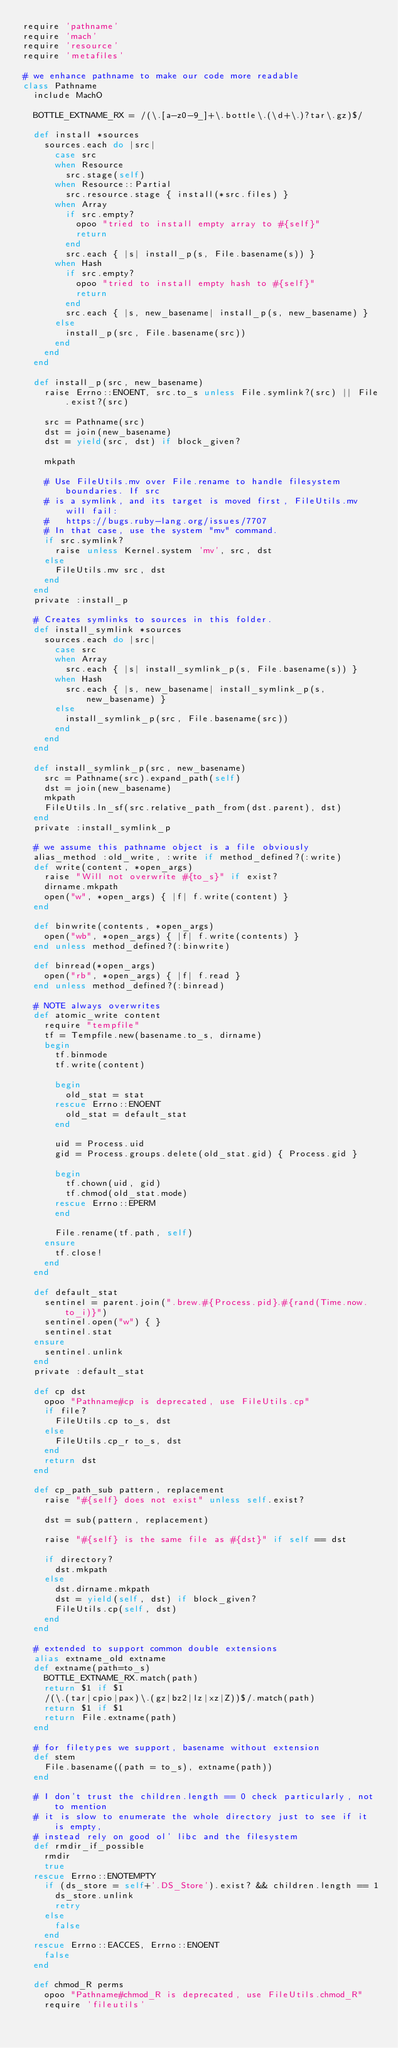Convert code to text. <code><loc_0><loc_0><loc_500><loc_500><_Ruby_>require 'pathname'
require 'mach'
require 'resource'
require 'metafiles'

# we enhance pathname to make our code more readable
class Pathname
  include MachO

  BOTTLE_EXTNAME_RX = /(\.[a-z0-9_]+\.bottle\.(\d+\.)?tar\.gz)$/

  def install *sources
    sources.each do |src|
      case src
      when Resource
        src.stage(self)
      when Resource::Partial
        src.resource.stage { install(*src.files) }
      when Array
        if src.empty?
          opoo "tried to install empty array to #{self}"
          return
        end
        src.each { |s| install_p(s, File.basename(s)) }
      when Hash
        if src.empty?
          opoo "tried to install empty hash to #{self}"
          return
        end
        src.each { |s, new_basename| install_p(s, new_basename) }
      else
        install_p(src, File.basename(src))
      end
    end
  end

  def install_p(src, new_basename)
    raise Errno::ENOENT, src.to_s unless File.symlink?(src) || File.exist?(src)

    src = Pathname(src)
    dst = join(new_basename)
    dst = yield(src, dst) if block_given?

    mkpath

    # Use FileUtils.mv over File.rename to handle filesystem boundaries. If src
    # is a symlink, and its target is moved first, FileUtils.mv will fail:
    #   https://bugs.ruby-lang.org/issues/7707
    # In that case, use the system "mv" command.
    if src.symlink?
      raise unless Kernel.system 'mv', src, dst
    else
      FileUtils.mv src, dst
    end
  end
  private :install_p

  # Creates symlinks to sources in this folder.
  def install_symlink *sources
    sources.each do |src|
      case src
      when Array
        src.each { |s| install_symlink_p(s, File.basename(s)) }
      when Hash
        src.each { |s, new_basename| install_symlink_p(s, new_basename) }
      else
        install_symlink_p(src, File.basename(src))
      end
    end
  end

  def install_symlink_p(src, new_basename)
    src = Pathname(src).expand_path(self)
    dst = join(new_basename)
    mkpath
    FileUtils.ln_sf(src.relative_path_from(dst.parent), dst)
  end
  private :install_symlink_p

  # we assume this pathname object is a file obviously
  alias_method :old_write, :write if method_defined?(:write)
  def write(content, *open_args)
    raise "Will not overwrite #{to_s}" if exist?
    dirname.mkpath
    open("w", *open_args) { |f| f.write(content) }
  end

  def binwrite(contents, *open_args)
    open("wb", *open_args) { |f| f.write(contents) }
  end unless method_defined?(:binwrite)

  def binread(*open_args)
    open("rb", *open_args) { |f| f.read }
  end unless method_defined?(:binread)

  # NOTE always overwrites
  def atomic_write content
    require "tempfile"
    tf = Tempfile.new(basename.to_s, dirname)
    begin
      tf.binmode
      tf.write(content)

      begin
        old_stat = stat
      rescue Errno::ENOENT
        old_stat = default_stat
      end

      uid = Process.uid
      gid = Process.groups.delete(old_stat.gid) { Process.gid }

      begin
        tf.chown(uid, gid)
        tf.chmod(old_stat.mode)
      rescue Errno::EPERM
      end

      File.rename(tf.path, self)
    ensure
      tf.close!
    end
  end

  def default_stat
    sentinel = parent.join(".brew.#{Process.pid}.#{rand(Time.now.to_i)}")
    sentinel.open("w") { }
    sentinel.stat
  ensure
    sentinel.unlink
  end
  private :default_stat

  def cp dst
    opoo "Pathname#cp is deprecated, use FileUtils.cp"
    if file?
      FileUtils.cp to_s, dst
    else
      FileUtils.cp_r to_s, dst
    end
    return dst
  end

  def cp_path_sub pattern, replacement
    raise "#{self} does not exist" unless self.exist?

    dst = sub(pattern, replacement)

    raise "#{self} is the same file as #{dst}" if self == dst

    if directory?
      dst.mkpath
    else
      dst.dirname.mkpath
      dst = yield(self, dst) if block_given?
      FileUtils.cp(self, dst)
    end
  end

  # extended to support common double extensions
  alias extname_old extname
  def extname(path=to_s)
    BOTTLE_EXTNAME_RX.match(path)
    return $1 if $1
    /(\.(tar|cpio|pax)\.(gz|bz2|lz|xz|Z))$/.match(path)
    return $1 if $1
    return File.extname(path)
  end

  # for filetypes we support, basename without extension
  def stem
    File.basename((path = to_s), extname(path))
  end

  # I don't trust the children.length == 0 check particularly, not to mention
  # it is slow to enumerate the whole directory just to see if it is empty,
  # instead rely on good ol' libc and the filesystem
  def rmdir_if_possible
    rmdir
    true
  rescue Errno::ENOTEMPTY
    if (ds_store = self+'.DS_Store').exist? && children.length == 1
      ds_store.unlink
      retry
    else
      false
    end
  rescue Errno::EACCES, Errno::ENOENT
    false
  end

  def chmod_R perms
    opoo "Pathname#chmod_R is deprecated, use FileUtils.chmod_R"
    require 'fileutils'</code> 